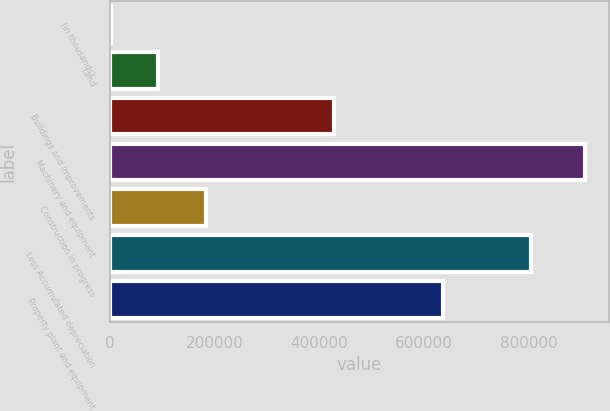Convert chart to OTSL. <chart><loc_0><loc_0><loc_500><loc_500><bar_chart><fcel>(in thousands)<fcel>Land<fcel>Buildings and improvements<fcel>Machinery and equipment<fcel>Construction in progress<fcel>Less Accumulated depreciation<fcel>Property plant and equipment<nl><fcel>2013<fcel>92565.8<fcel>427826<fcel>907541<fcel>183119<fcel>805394<fcel>637172<nl></chart> 